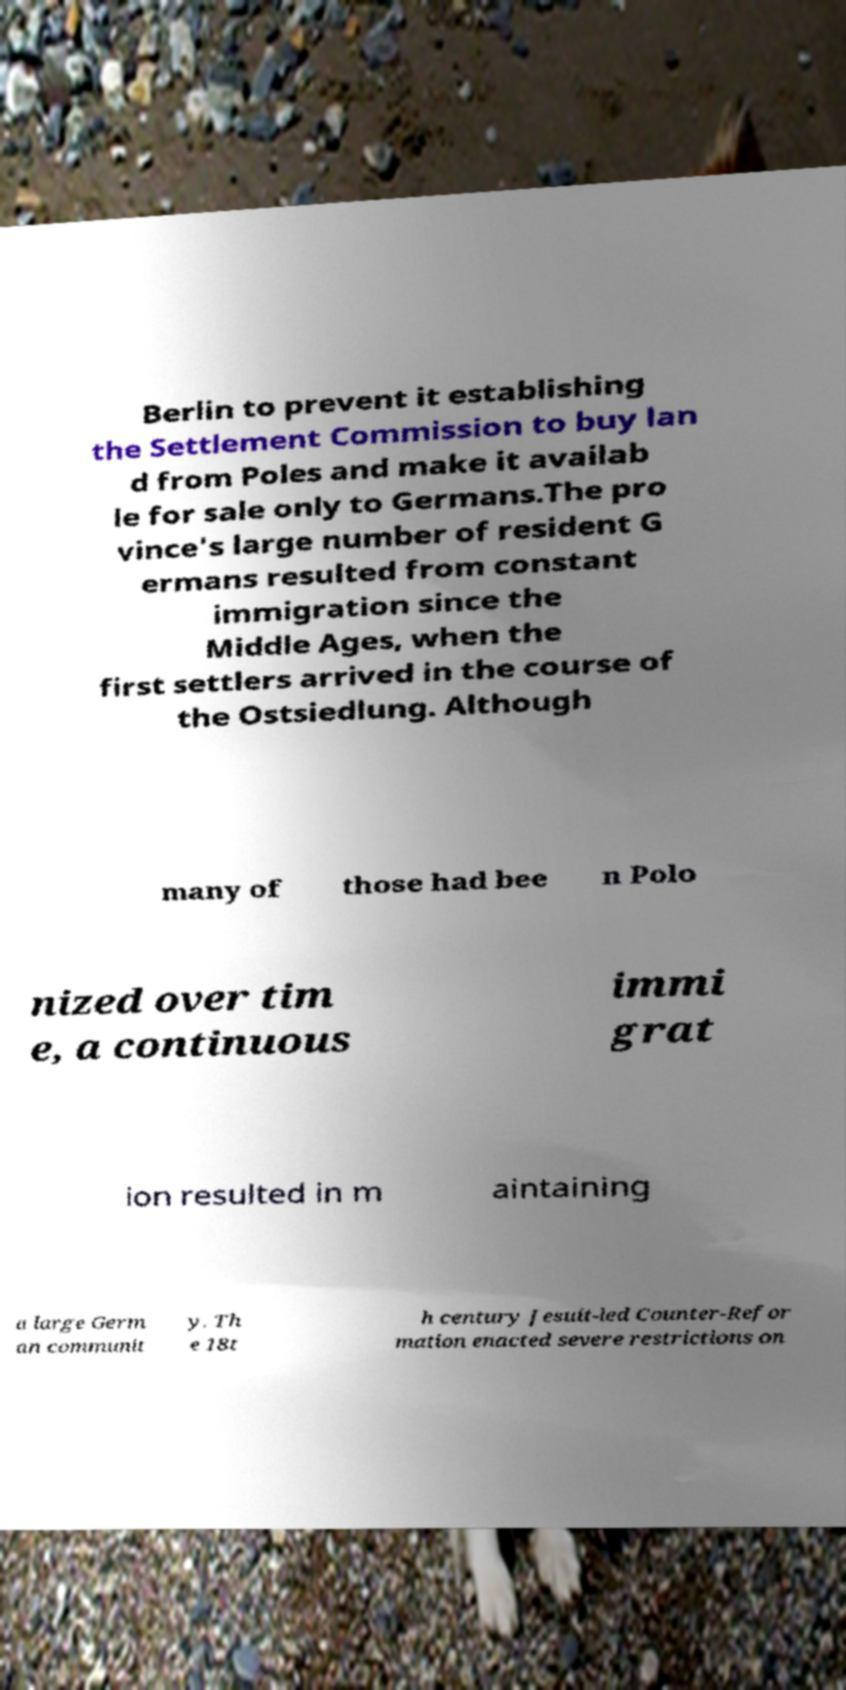Can you read and provide the text displayed in the image?This photo seems to have some interesting text. Can you extract and type it out for me? Berlin to prevent it establishing the Settlement Commission to buy lan d from Poles and make it availab le for sale only to Germans.The pro vince's large number of resident G ermans resulted from constant immigration since the Middle Ages, when the first settlers arrived in the course of the Ostsiedlung. Although many of those had bee n Polo nized over tim e, a continuous immi grat ion resulted in m aintaining a large Germ an communit y. Th e 18t h century Jesuit-led Counter-Refor mation enacted severe restrictions on 